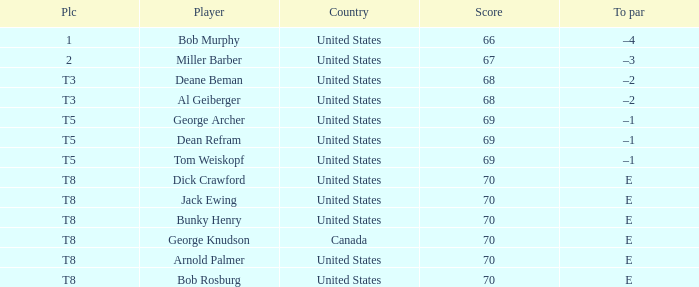Where did Bob Murphy of the United States place? 1.0. 